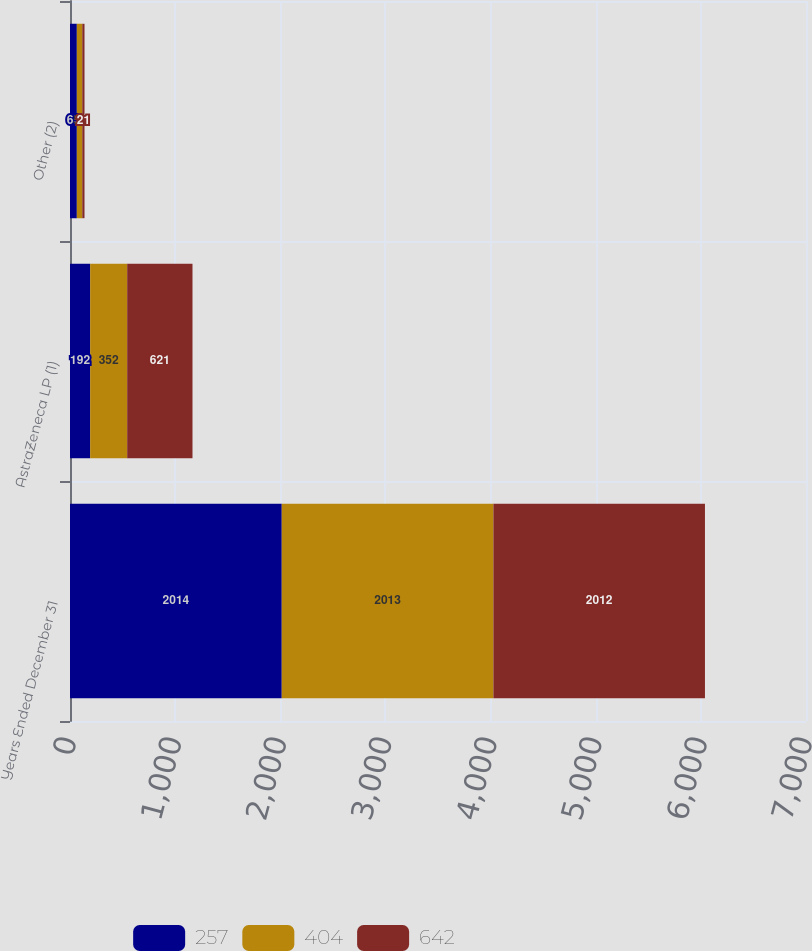Convert chart. <chart><loc_0><loc_0><loc_500><loc_500><stacked_bar_chart><ecel><fcel>Years Ended December 31<fcel>AstraZeneca LP (1)<fcel>Other (2)<nl><fcel>257<fcel>2014<fcel>192<fcel>65<nl><fcel>404<fcel>2013<fcel>352<fcel>52<nl><fcel>642<fcel>2012<fcel>621<fcel>21<nl></chart> 